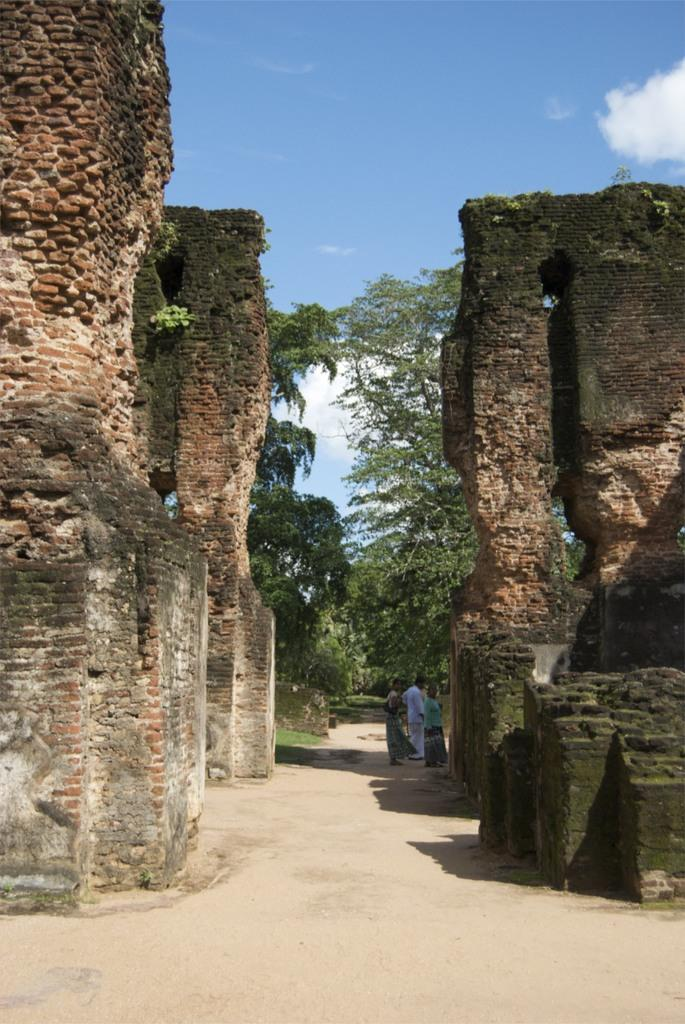What can be seen on both sides of the image? There are collapsed buildings on both the left and right sides of the image. What is happening in the middle of the image? There are persons standing on the ground in the middle of the image. What can be seen in the background of the image? There are trees and clouds in the sky in the background of the image. What type of wood is being used to write the prose in the image? There is no wood or prose present in the image; it features collapsed buildings and people standing on the ground. What payment method is being used by the persons in the image? There is no payment method being used in the image; it focuses on the aftermath of a collapse and people standing on the ground. 